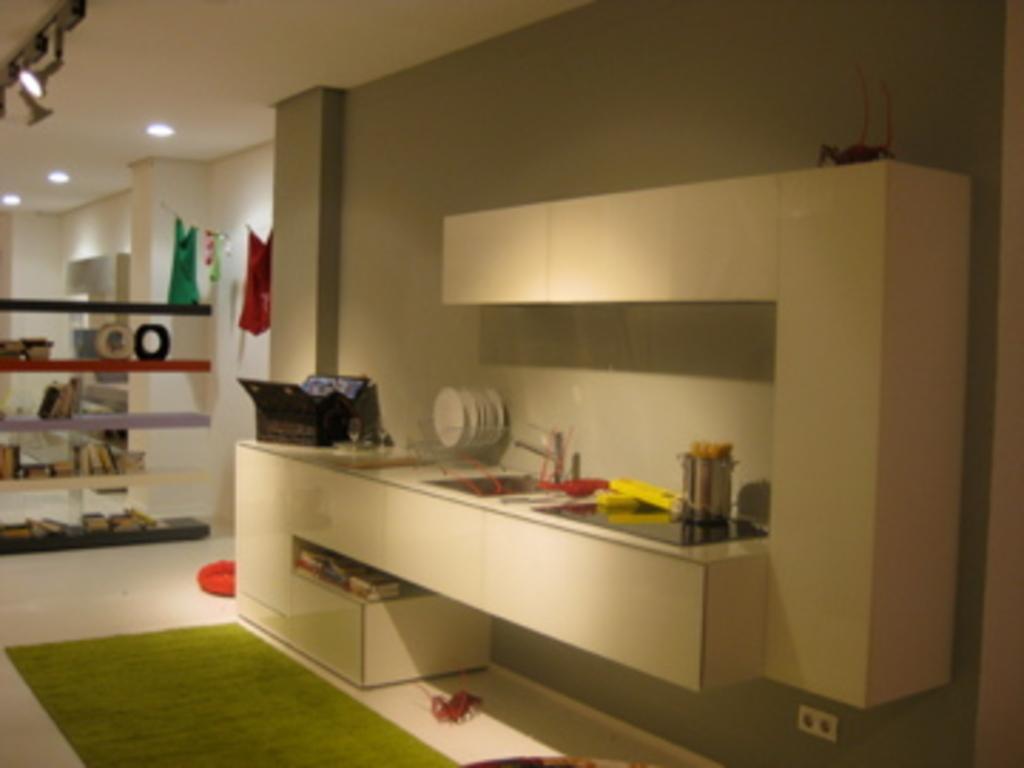Please provide a concise description of this image. On the right side, we see a grey wall and a counter top or a cupboard on which a vessel, plates stand and a black color object are placed. We see a wash basin. At the bottom, we see the floor in white and green color. Beside that, we see an object in red color. In the middle, we see a rack in which the books and some other objects are placed. Beside that, we see the clothes are hanged on the rope. In the background, we see the pillars and a wall in white color. 